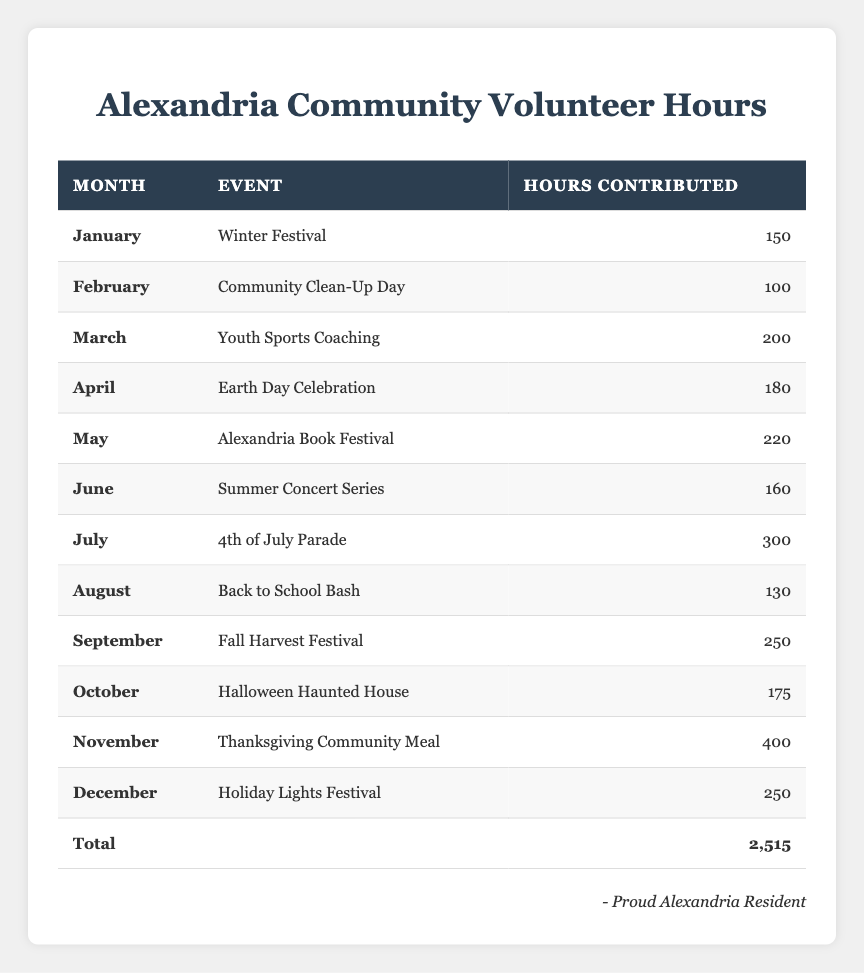What is the total number of volunteer hours contributed in November? In November, the Volunteer Hours table shows that 400 hours were contributed to the Thanksgiving Community Meal event.
Answer: 400 Which month had the highest volunteer hours? The month with the highest hours is July, where 300 hours were contributed to the 4th of July Parade event.
Answer: July What is the average number of volunteer hours contributed per month? To find the average, sum the total hours (2,515) and divide by the number of months (12). The calculation is 2,515 / 12 = approximately 209.58.
Answer: 209.58 Was the total volunteer hours in December greater than that in February? December had 250 hours contributed, while February had 100 hours. Since 250 is greater than 100, the answer is yes.
Answer: Yes Which event contributed the most volunteer hours and in which month did it occur? The event with the most hours is the Thanksgiving Community Meal in November with 400 hours.
Answer: Thanksgiving Community Meal, November How many more hours were contributed in September than in April? September had 250 hours and April had 180 hours. The difference is 250 - 180 = 70 hours.
Answer: 70 Did the total hours in the first half of the year exceed those in the second half? For the first half: January (150) + February (100) + March (200) + April (180) + May (220) + June (160) = 1,110. For the second half: July (300) + August (130) + September (250) + October (175) + November (400) + December (250) = 1,505. Since 1,110 < 1,505, the answer is no.
Answer: No In which month did volunteers contribute the least number of hours, and how many hours was that? February contributed the least number of hours, with a total of 100 hours for the Community Clean-Up Day event.
Answer: February, 100 What is the combined total of volunteer hours contributed in May and June? In May, 220 hours were contributed, and in June, 160 hours were contributed. The total is 220 + 160 = 380 hours.
Answer: 380 How many months had volunteer hours greater than 200? The months with hours greater than 200 are March (200), May (220), July (300), September (250), and November (400). That's a total of 5 months.
Answer: 5 Which two months had the closest number of hours contributed, and what was that number? In June, there were 160 hours contributed, and in August, there were 130 hours. The closest are October (175) and August (130). The nearest is a difference of 45 hours.
Answer: October and August, 45 difference 